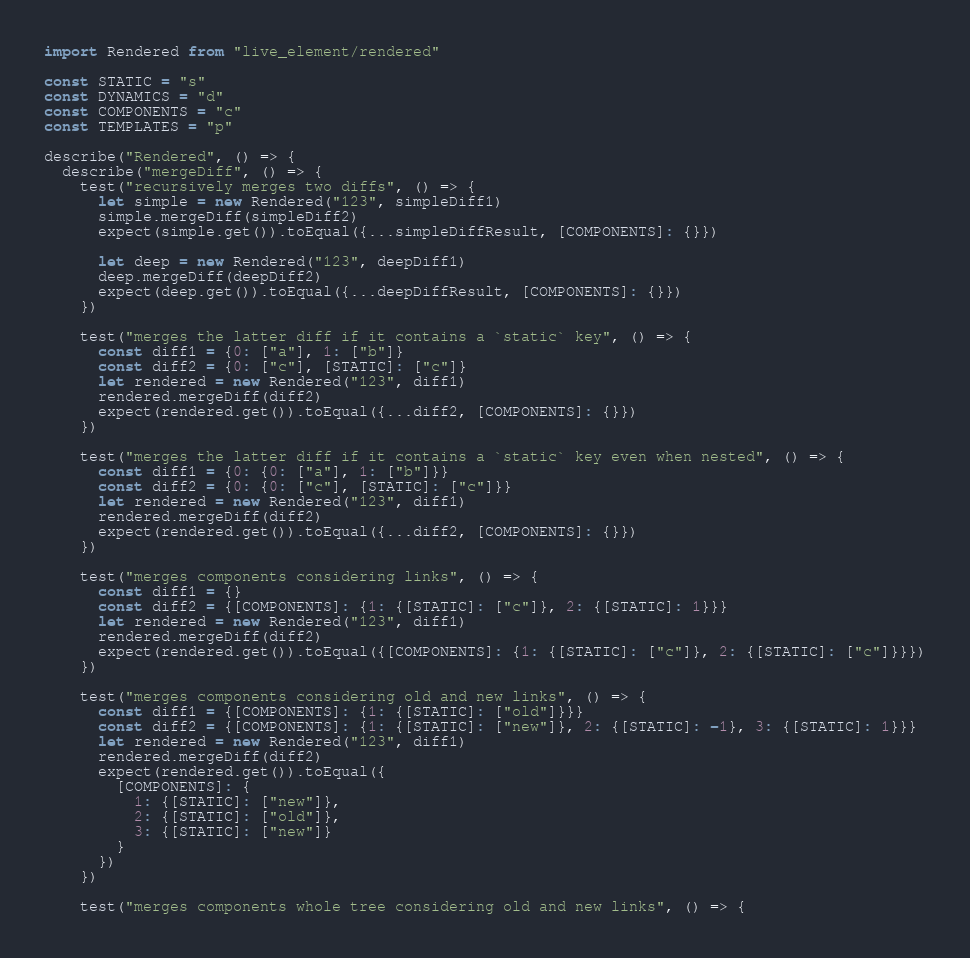Convert code to text. <code><loc_0><loc_0><loc_500><loc_500><_JavaScript_>import Rendered from "live_element/rendered"

const STATIC = "s"
const DYNAMICS = "d"
const COMPONENTS = "c"
const TEMPLATES = "p"

describe("Rendered", () => {
  describe("mergeDiff", () => {
    test("recursively merges two diffs", () => {
      let simple = new Rendered("123", simpleDiff1)
      simple.mergeDiff(simpleDiff2)
      expect(simple.get()).toEqual({...simpleDiffResult, [COMPONENTS]: {}})

      let deep = new Rendered("123", deepDiff1)
      deep.mergeDiff(deepDiff2)
      expect(deep.get()).toEqual({...deepDiffResult, [COMPONENTS]: {}})
    })

    test("merges the latter diff if it contains a `static` key", () => {
      const diff1 = {0: ["a"], 1: ["b"]}
      const diff2 = {0: ["c"], [STATIC]: ["c"]}
      let rendered = new Rendered("123", diff1)
      rendered.mergeDiff(diff2)
      expect(rendered.get()).toEqual({...diff2, [COMPONENTS]: {}})
    })

    test("merges the latter diff if it contains a `static` key even when nested", () => {
      const diff1 = {0: {0: ["a"], 1: ["b"]}}
      const diff2 = {0: {0: ["c"], [STATIC]: ["c"]}}
      let rendered = new Rendered("123", diff1)
      rendered.mergeDiff(diff2)
      expect(rendered.get()).toEqual({...diff2, [COMPONENTS]: {}})
    })

    test("merges components considering links", () => {
      const diff1 = {}
      const diff2 = {[COMPONENTS]: {1: {[STATIC]: ["c"]}, 2: {[STATIC]: 1}}}
      let rendered = new Rendered("123", diff1)
      rendered.mergeDiff(diff2)
      expect(rendered.get()).toEqual({[COMPONENTS]: {1: {[STATIC]: ["c"]}, 2: {[STATIC]: ["c"]}}})
    })

    test("merges components considering old and new links", () => {
      const diff1 = {[COMPONENTS]: {1: {[STATIC]: ["old"]}}}
      const diff2 = {[COMPONENTS]: {1: {[STATIC]: ["new"]}, 2: {[STATIC]: -1}, 3: {[STATIC]: 1}}}
      let rendered = new Rendered("123", diff1)
      rendered.mergeDiff(diff2)
      expect(rendered.get()).toEqual({
        [COMPONENTS]: {
          1: {[STATIC]: ["new"]},
          2: {[STATIC]: ["old"]},
          3: {[STATIC]: ["new"]}
        }
      })
    })

    test("merges components whole tree considering old and new links", () => {</code> 